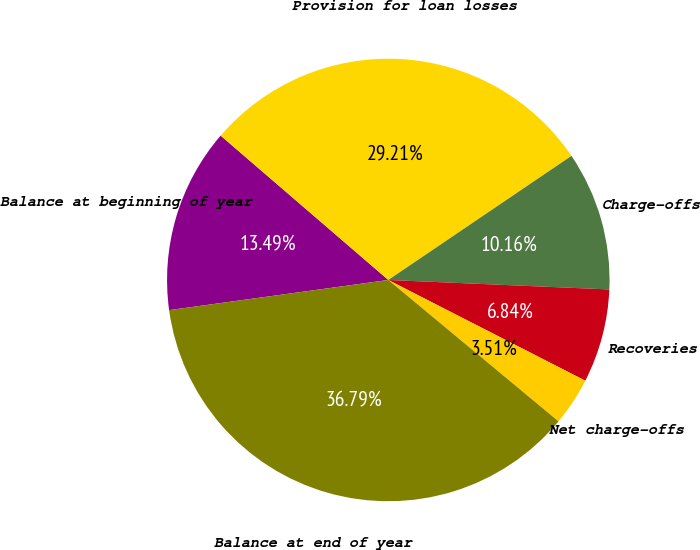<chart> <loc_0><loc_0><loc_500><loc_500><pie_chart><fcel>Balance at beginning of year<fcel>Provision for loan losses<fcel>Charge-offs<fcel>Recoveries<fcel>Net charge-offs<fcel>Balance at end of year<nl><fcel>13.49%<fcel>29.21%<fcel>10.16%<fcel>6.84%<fcel>3.51%<fcel>36.79%<nl></chart> 